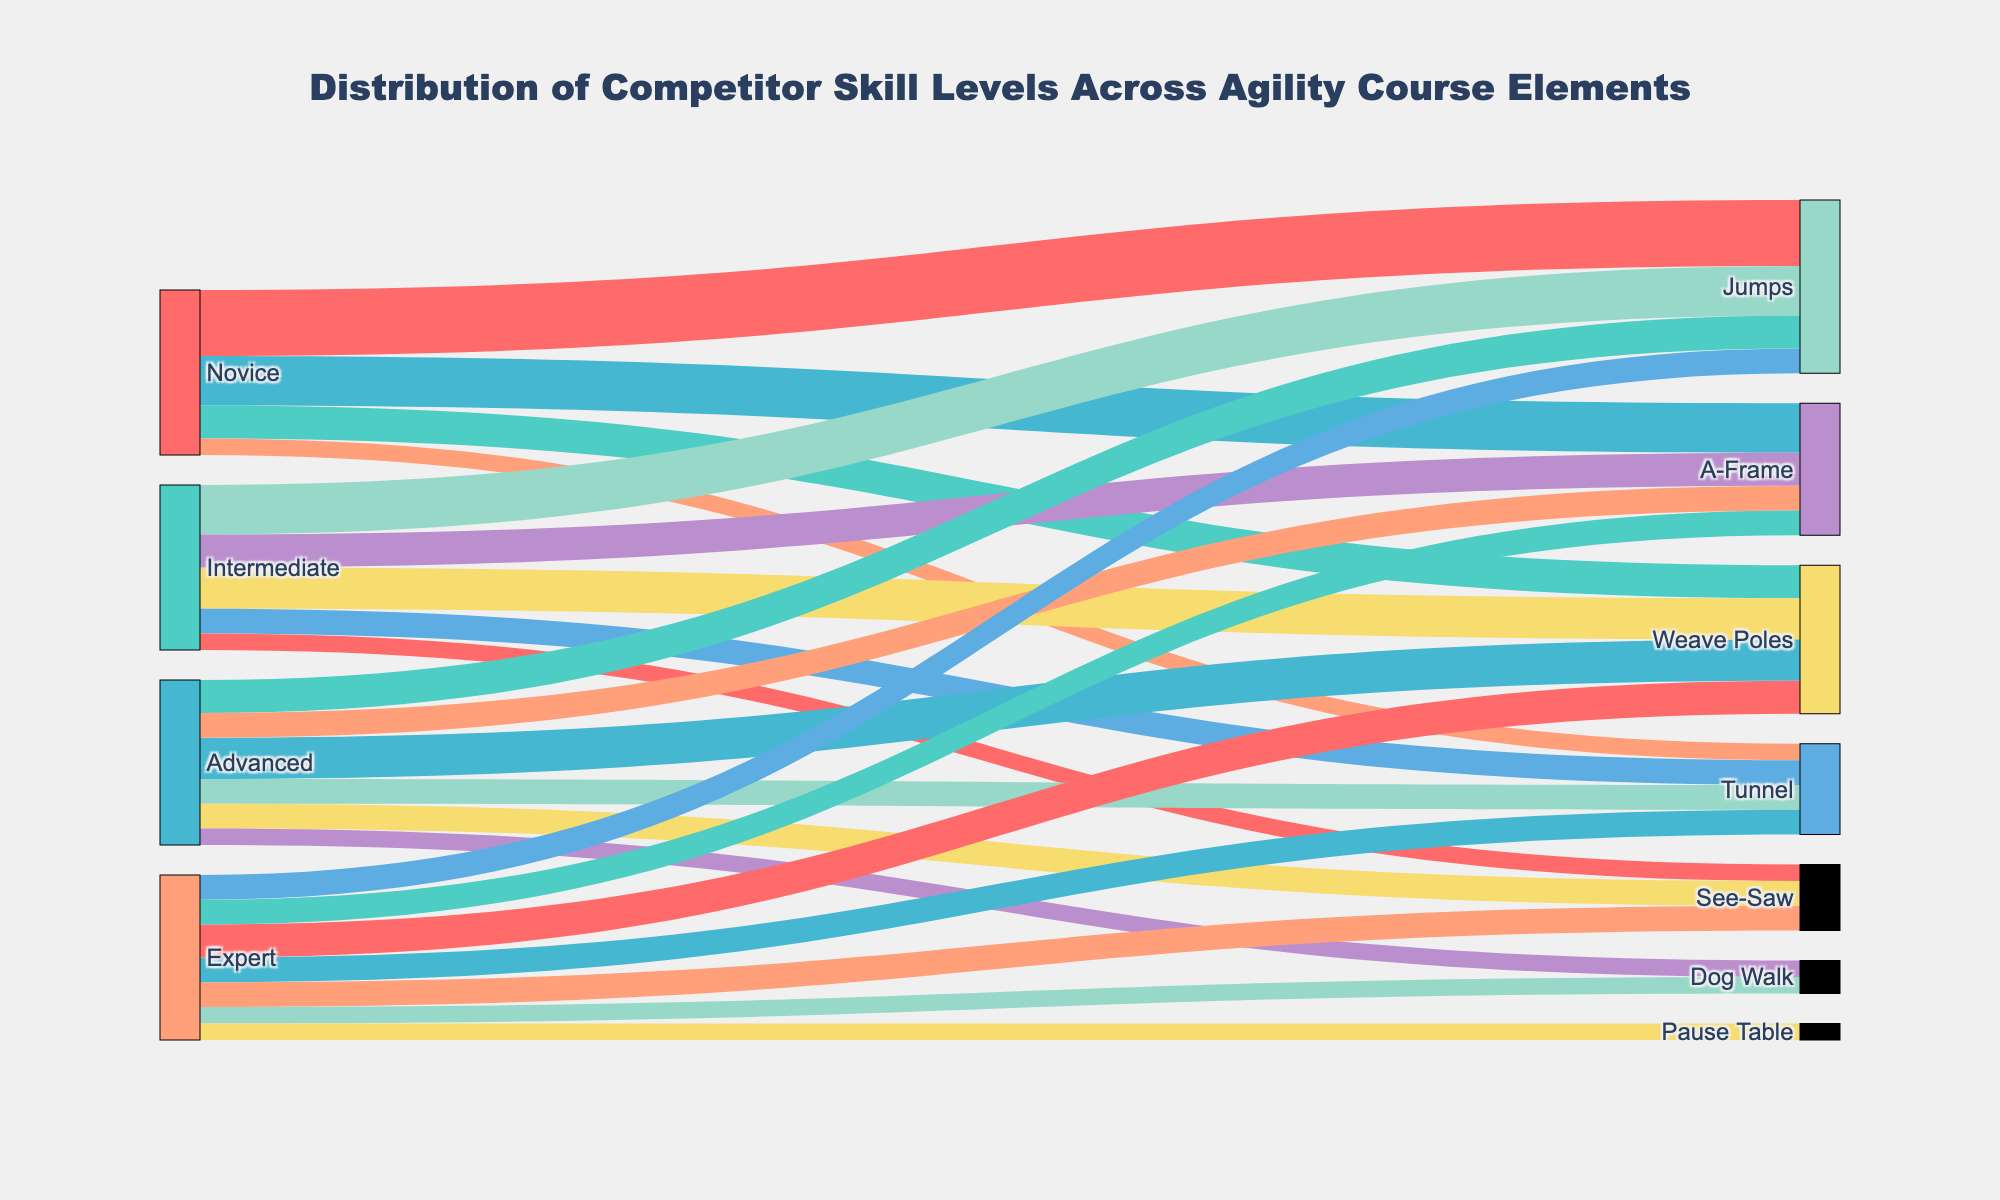What is the total number of competitors at the Novice level across all course elements? We need to sum the values for all course elements associated with "Novice". The values are 40 (Jumps), 20 (Weave Poles), 30 (A-Frame), and 10 (Tunnel). Summing these up: 40 + 20 + 30 + 10 = 100.
Answer: 100 Which course element has the highest number of competitors at the Expert level? By comparing the values for the "Expert" level across different course elements: 15 (Jumps), 20 (Weave Poles), 15 (A-Frame), 15 (Tunnel), 15 (See-Saw), 10 (Dog Walk), and 10 (Pause Table), the highest number is 20 for Weave Poles.
Answer: Weave Poles How many competitors are there in total for the See-Saw element? We need to sum the values for all skill levels associated with "See-Saw". The values are 10 (Intermediate), 15 (Advanced), and 15 (Expert). Summing these up: 10 + 15 + 15 = 40.
Answer: 40 Are there more Advanced or Intermediate competitors for the Jumps element? Comparing the values for "Jumps" at the Advanced level (20) and the Intermediate level (30), it is clear that Intermediate has more competitors.
Answer: Intermediate What is the combined total number of competitors for the Tunnel and Jumps elements at the Novice level? Adding the values for the "Tunnel" (10) and "Jumps" (40) elements at the Novice level: 10 + 40 = 50.
Answer: 50 Which skill level has the most variation in the number of competitors across different course elements? To determine this, observe the range (difference between the highest and lowest values) for each skill level:
- Novice: 30 (max) - 10 (min) = 20
- Intermediate: 30 (max) - 10 (min) = 20
- Advanced: 25 (max) - 10 (min) = 15
- Expert: 20 (max) - 10 (min) = 10
The Novice and Intermediate levels have the highest variation of 20.
Answer: Novice and Intermediate What is the total number of competitors participating in the Dog Walk element? We need to sum the values for all skill levels associated with "Dog Walk". The values are 10 (Advanced) and 10 (Expert). Summing these up: 10 + 10 = 20.
Answer: 20 Which course element is equally popular among Expert level competitors? Observing the values for "Expert" level competitors, we see that A-Frame, Tunnel, and See-Saw each have 15 competitors.
Answer: A-Frame, Tunnel, and See-Saw 